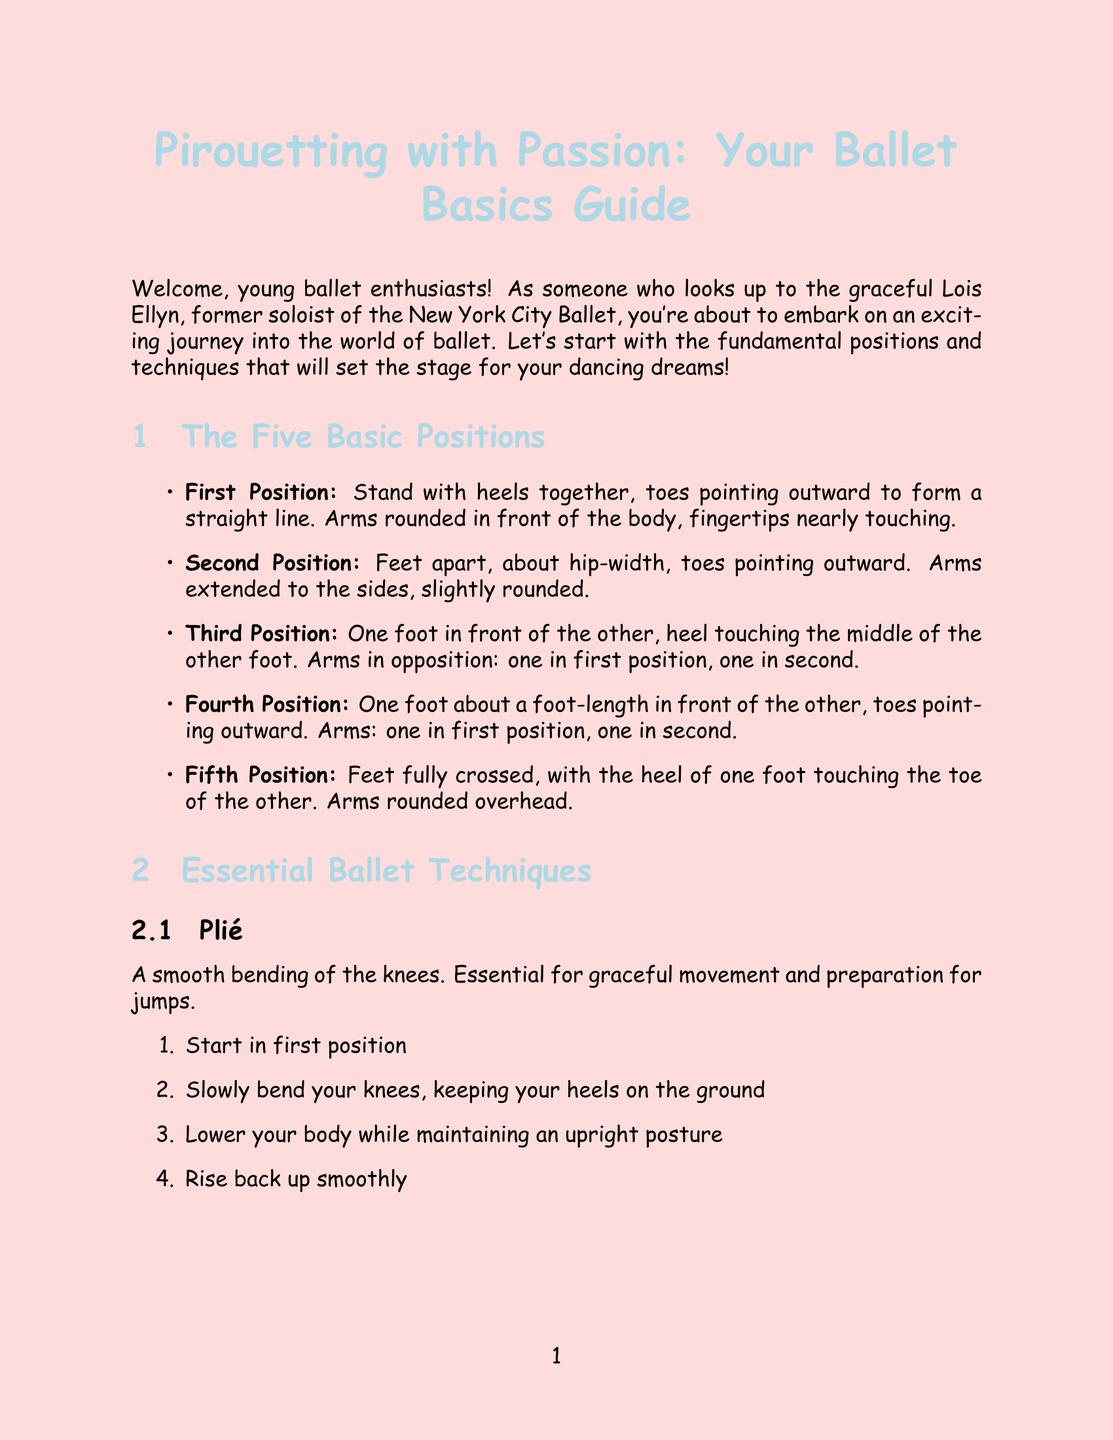What is the newsletter title? The title is stated at the very beginning of the document, which is "Pirouetting with Passion: Your Ballet Basics Guide."
Answer: Pirouetting with Passion: Your Ballet Basics Guide Who is the role model mentioned in the introduction? The introduction specifically mentions Lois Ellyn as a role model for young ballet enthusiasts.
Answer: Lois Ellyn How many essential ballet techniques are described in the document? The document lists three essential ballet techniques under the respective section.
Answer: 3 What is the first position in ballet? The first position is defined in the section detailing the five basic positions, which states to stand with heels together and toes pointing outward.
Answer: Stand with heels together, toes pointing outward What should a beginner aim for in their weekly practice goal? The document outlines a specific goal for beginners to practice for at least 30 minutes every day.
Answer: 30 minutes Which ballet technique is described as "A smooth bending of the knees"? The description specifically refers to plié, which is mentioned in the section on essential ballet techniques.
Answer: Plié What type of resource is "Technical Manual and Dictionary of Classical Ballet"? The document categorizes it as a book in the recommended resources section.
Answer: Book What does Lois Ellyn emphasize regarding ballet in her quote? Her quote highlights that ballet serves as a foundation for all dance.
Answer: Foundation for all dance What is the last encouragement given to young dancers in the conclusion? The conclusion encourages young dancers by reaffirming their potential and passion for ballet.
Answer: Keep your chin up, your core engaged, and your passion burning bright 